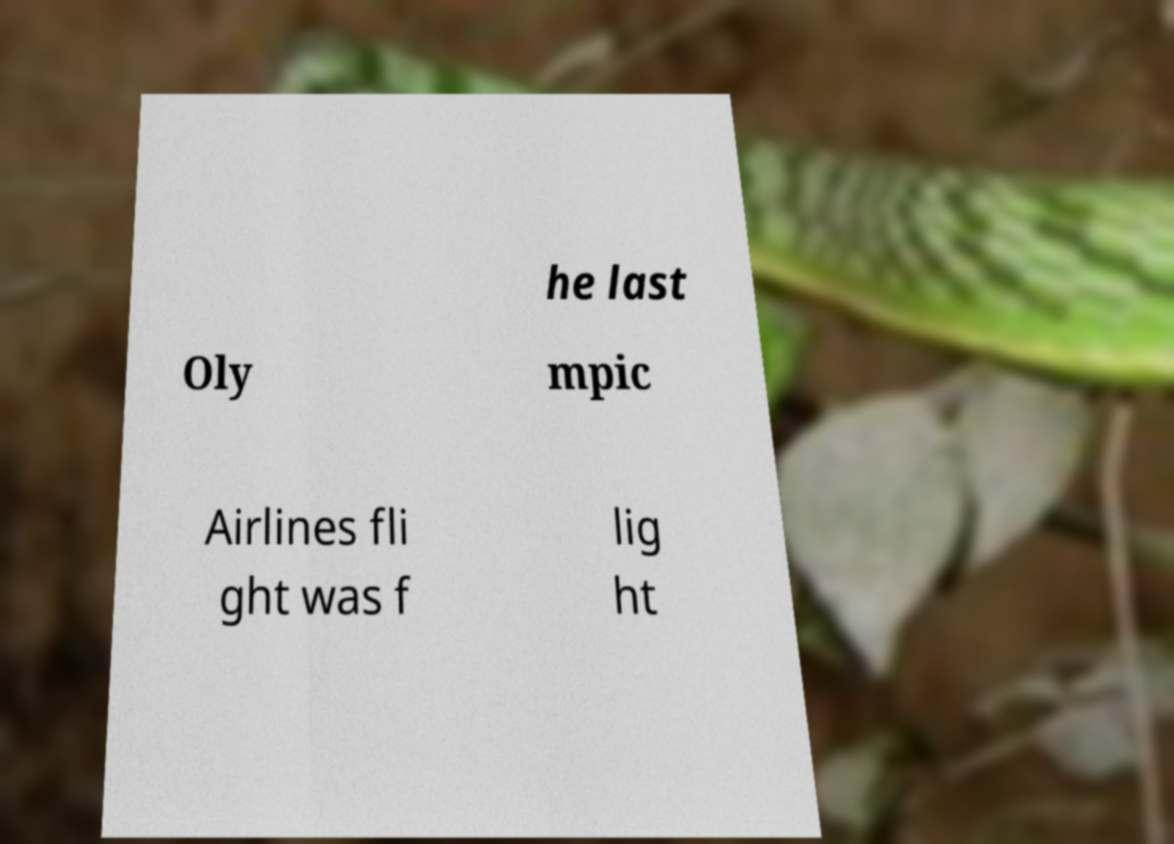What messages or text are displayed in this image? I need them in a readable, typed format. he last Oly mpic Airlines fli ght was f lig ht 